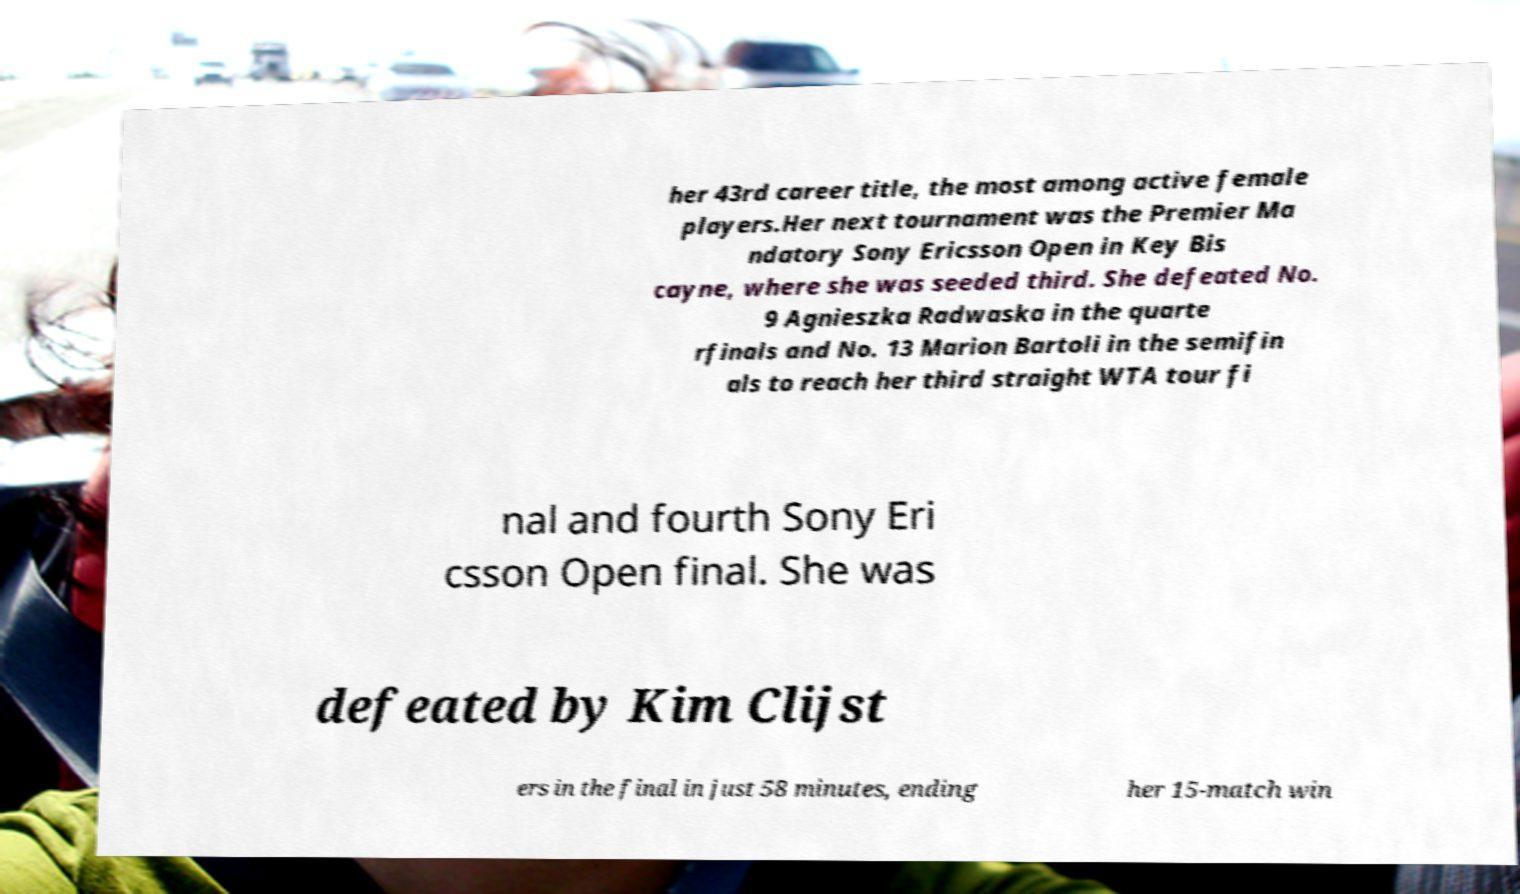Can you read and provide the text displayed in the image?This photo seems to have some interesting text. Can you extract and type it out for me? her 43rd career title, the most among active female players.Her next tournament was the Premier Ma ndatory Sony Ericsson Open in Key Bis cayne, where she was seeded third. She defeated No. 9 Agnieszka Radwaska in the quarte rfinals and No. 13 Marion Bartoli in the semifin als to reach her third straight WTA tour fi nal and fourth Sony Eri csson Open final. She was defeated by Kim Clijst ers in the final in just 58 minutes, ending her 15-match win 